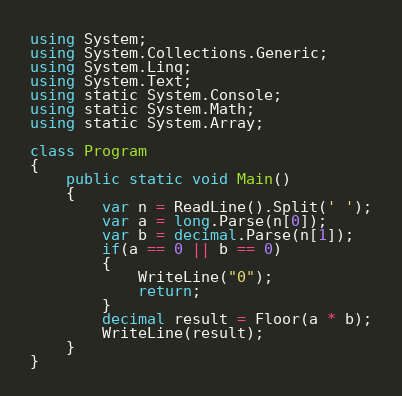<code> <loc_0><loc_0><loc_500><loc_500><_C#_>using System;
using System.Collections.Generic;
using System.Linq;
using System.Text;
using static System.Console;
using static System.Math;
using static System.Array;

class Program
{
    public static void Main()
    {
        var n = ReadLine().Split(' ');
        var a = long.Parse(n[0]);
        var b = decimal.Parse(n[1]);
        if(a == 0 || b == 0)
        {
            WriteLine("0");
            return;
        }
        decimal result = Floor(a * b);
        WriteLine(result);
    }
}</code> 